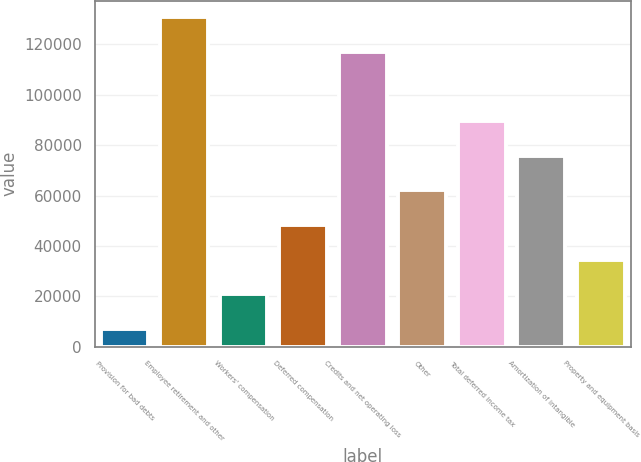Convert chart. <chart><loc_0><loc_0><loc_500><loc_500><bar_chart><fcel>Provision for bad debts<fcel>Employee retirement and other<fcel>Workers' compensation<fcel>Deferred compensation<fcel>Credits and net operating loss<fcel>Other<fcel>Total deferred income tax<fcel>Amortization of intangible<fcel>Property and equipment basis<nl><fcel>7123<fcel>130830<fcel>20868.2<fcel>48358.6<fcel>117085<fcel>62103.8<fcel>89594.2<fcel>75849<fcel>34613.4<nl></chart> 